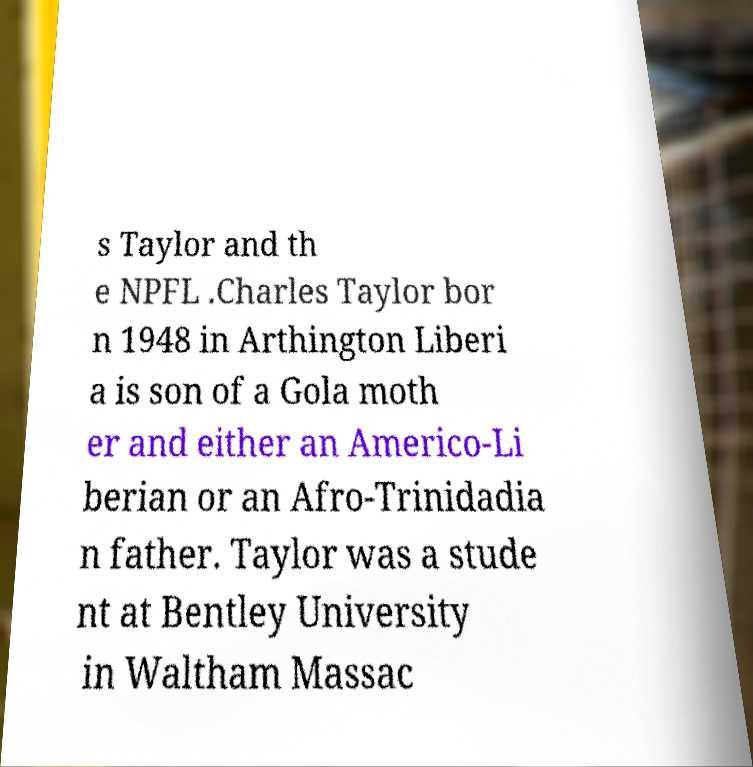I need the written content from this picture converted into text. Can you do that? s Taylor and th e NPFL .Charles Taylor bor n 1948 in Arthington Liberi a is son of a Gola moth er and either an Americo-Li berian or an Afro-Trinidadia n father. Taylor was a stude nt at Bentley University in Waltham Massac 